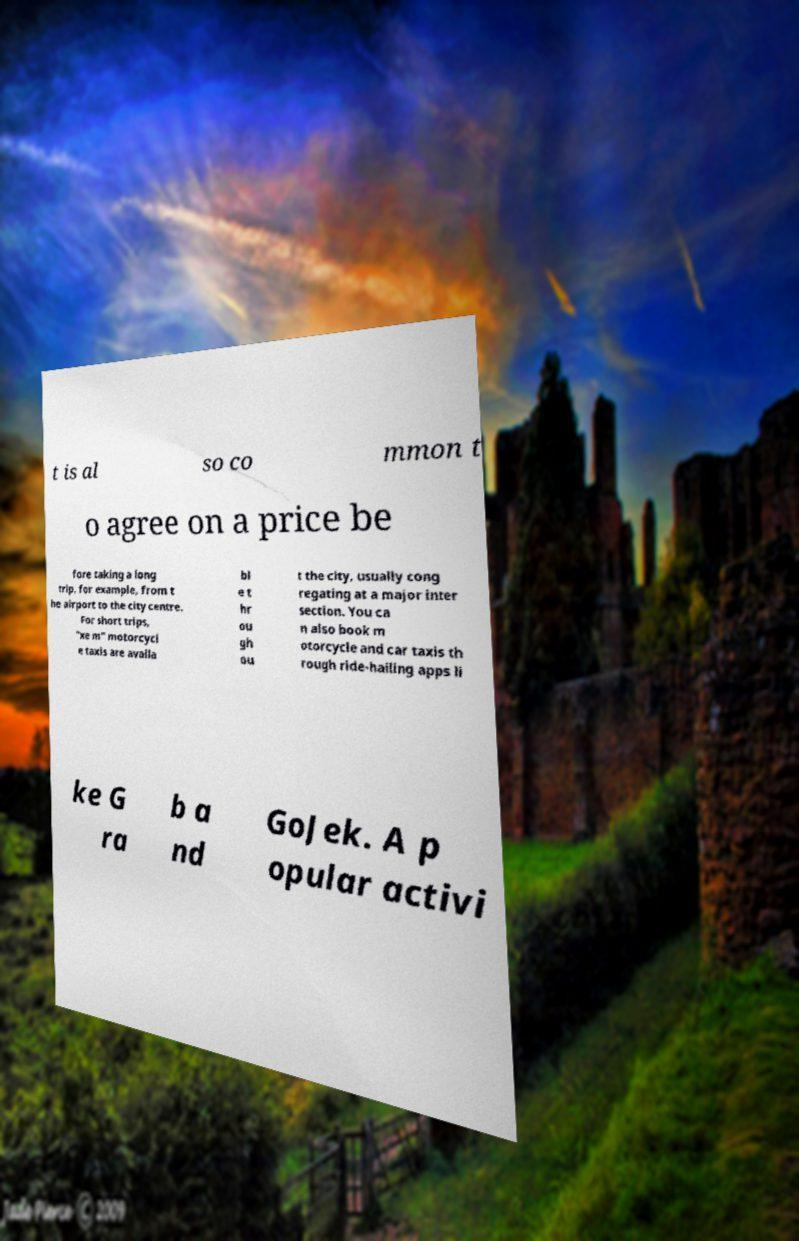Could you assist in decoding the text presented in this image and type it out clearly? t is al so co mmon t o agree on a price be fore taking a long trip, for example, from t he airport to the city centre. For short trips, "xe m" motorcycl e taxis are availa bl e t hr ou gh ou t the city, usually cong regating at a major inter section. You ca n also book m otorcycle and car taxis th rough ride-hailing apps li ke G ra b a nd GoJek. A p opular activi 